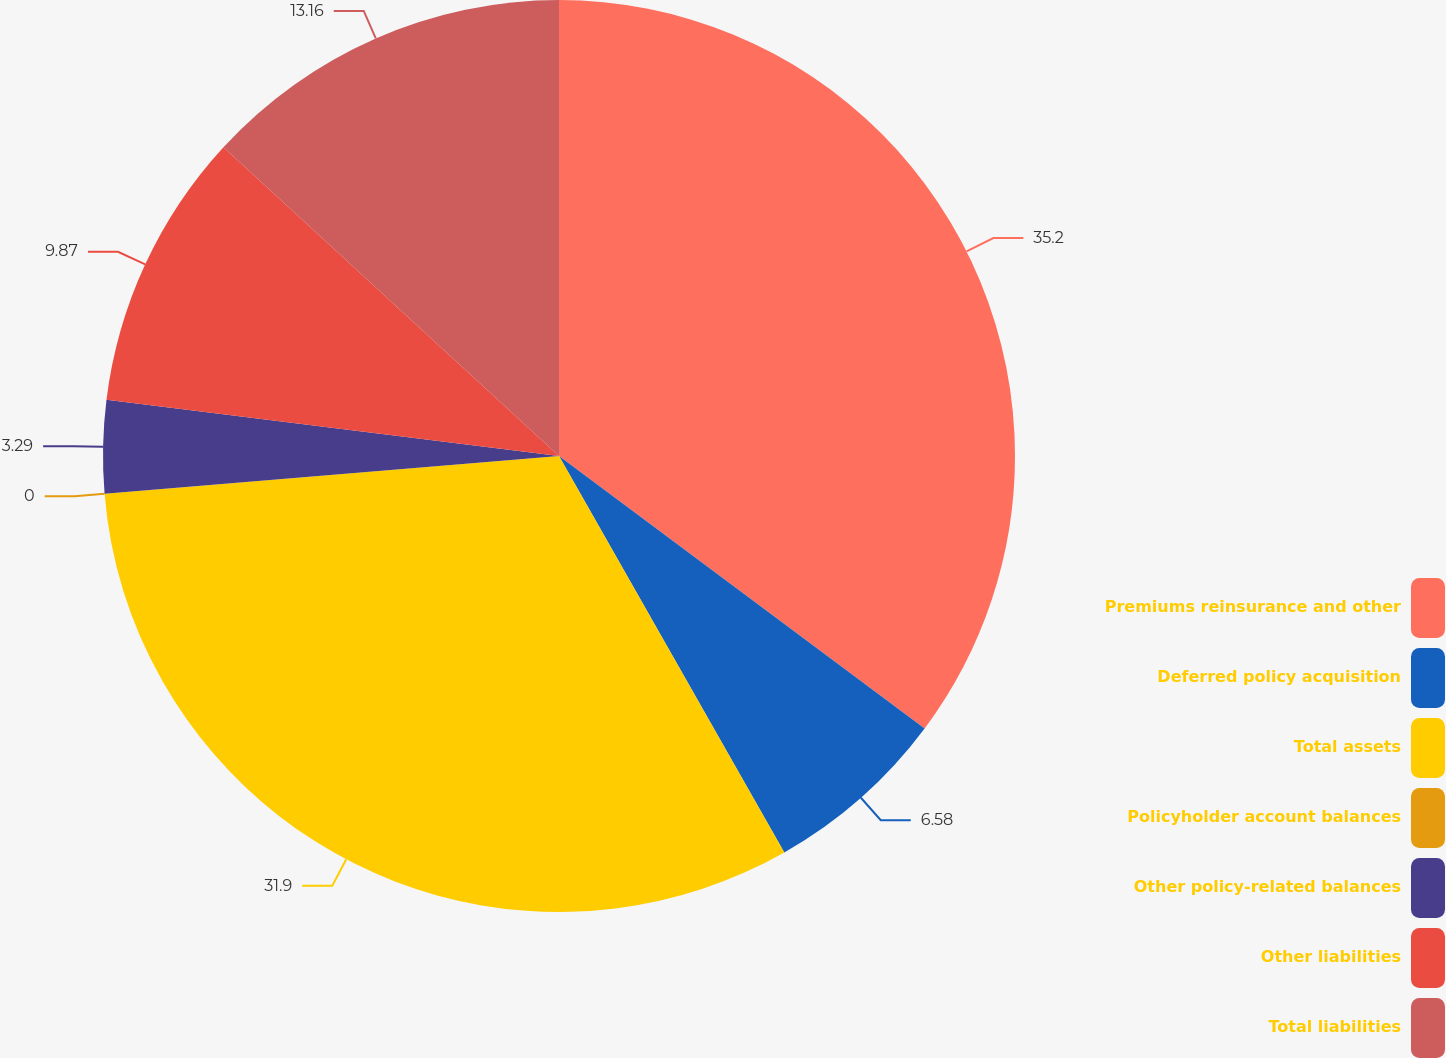<chart> <loc_0><loc_0><loc_500><loc_500><pie_chart><fcel>Premiums reinsurance and other<fcel>Deferred policy acquisition<fcel>Total assets<fcel>Policyholder account balances<fcel>Other policy-related balances<fcel>Other liabilities<fcel>Total liabilities<nl><fcel>35.19%<fcel>6.58%<fcel>31.9%<fcel>0.0%<fcel>3.29%<fcel>9.87%<fcel>13.16%<nl></chart> 